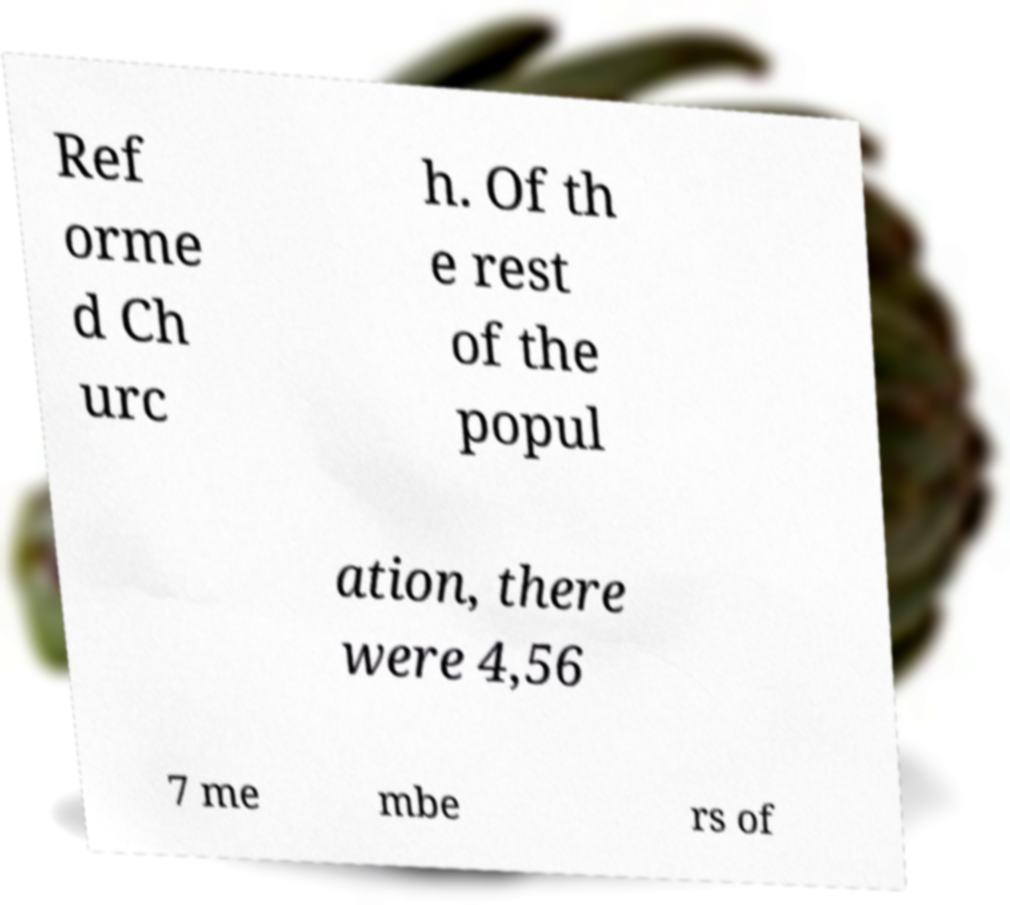What messages or text are displayed in this image? I need them in a readable, typed format. Ref orme d Ch urc h. Of th e rest of the popul ation, there were 4,56 7 me mbe rs of 